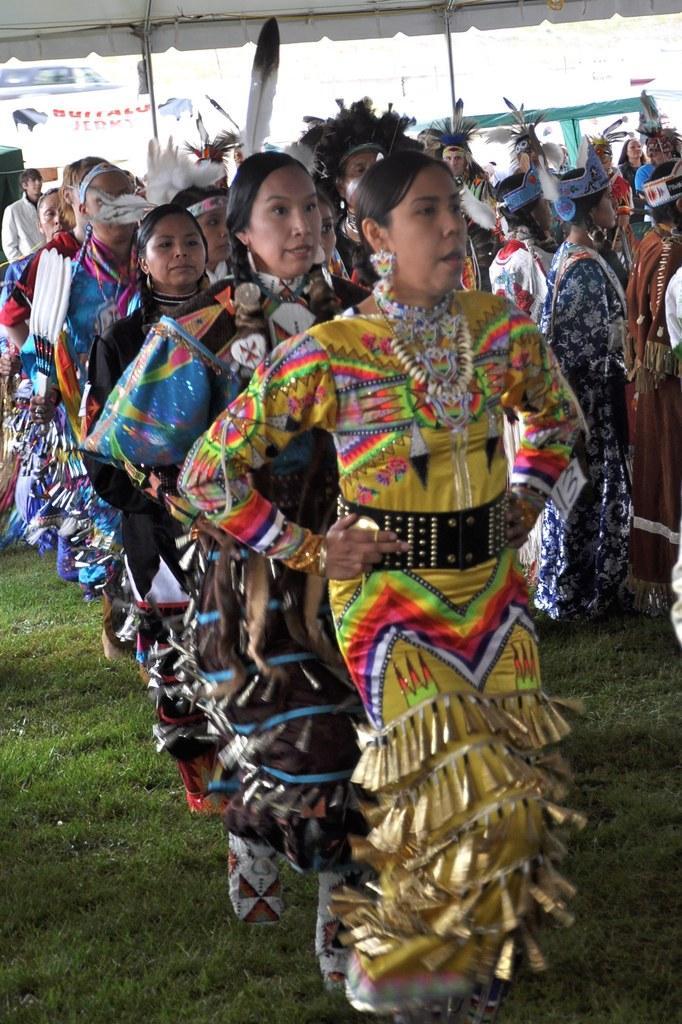Describe this image in one or two sentences. In this image, we can see a group of people. Few are walking and standing on the grass. Top of the image, we can see poles, tent, banners and vehicle. 